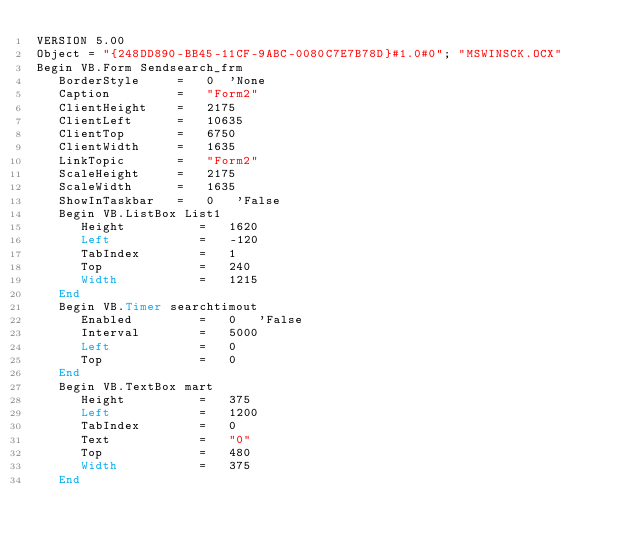Convert code to text. <code><loc_0><loc_0><loc_500><loc_500><_VisualBasic_>VERSION 5.00
Object = "{248DD890-BB45-11CF-9ABC-0080C7E7B78D}#1.0#0"; "MSWINSCK.OCX"
Begin VB.Form Sendsearch_frm 
   BorderStyle     =   0  'None
   Caption         =   "Form2"
   ClientHeight    =   2175
   ClientLeft      =   10635
   ClientTop       =   6750
   ClientWidth     =   1635
   LinkTopic       =   "Form2"
   ScaleHeight     =   2175
   ScaleWidth      =   1635
   ShowInTaskbar   =   0   'False
   Begin VB.ListBox List1 
      Height          =   1620
      Left            =   -120
      TabIndex        =   1
      Top             =   240
      Width           =   1215
   End
   Begin VB.Timer searchtimout 
      Enabled         =   0   'False
      Interval        =   5000
      Left            =   0
      Top             =   0
   End
   Begin VB.TextBox mart 
      Height          =   375
      Left            =   1200
      TabIndex        =   0
      Text            =   "0"
      Top             =   480
      Width           =   375
   End</code> 